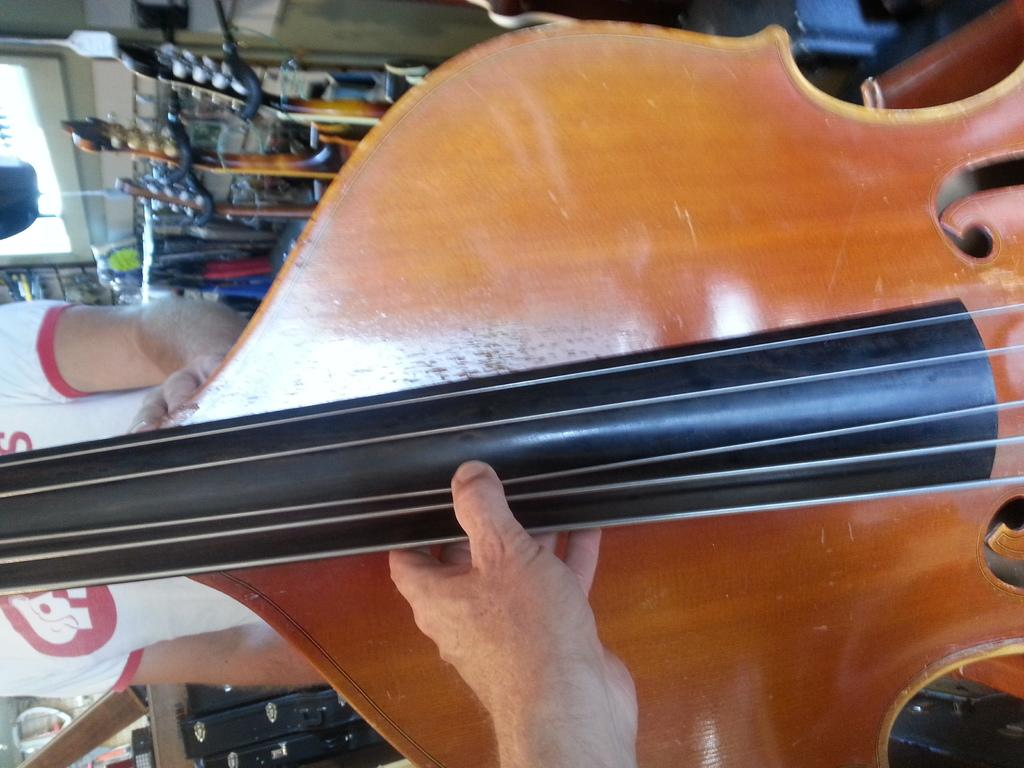What type of musical instrument is in the image? There is a brown and black violin in the image. Who is holding the violin? The violin is held by a person. Can you describe the person standing behind the violin? The person is wearing a white and red t-shirt. What other musical instruments can be seen in the image? There are other musical instruments visible in the image. What type of news can be seen on the boats in the image? There are no boats or news present in the image; it features a violin and other musical instruments. What angle is the violin being played at in the image? The angle at which the violin is being played cannot be determined from the image. 